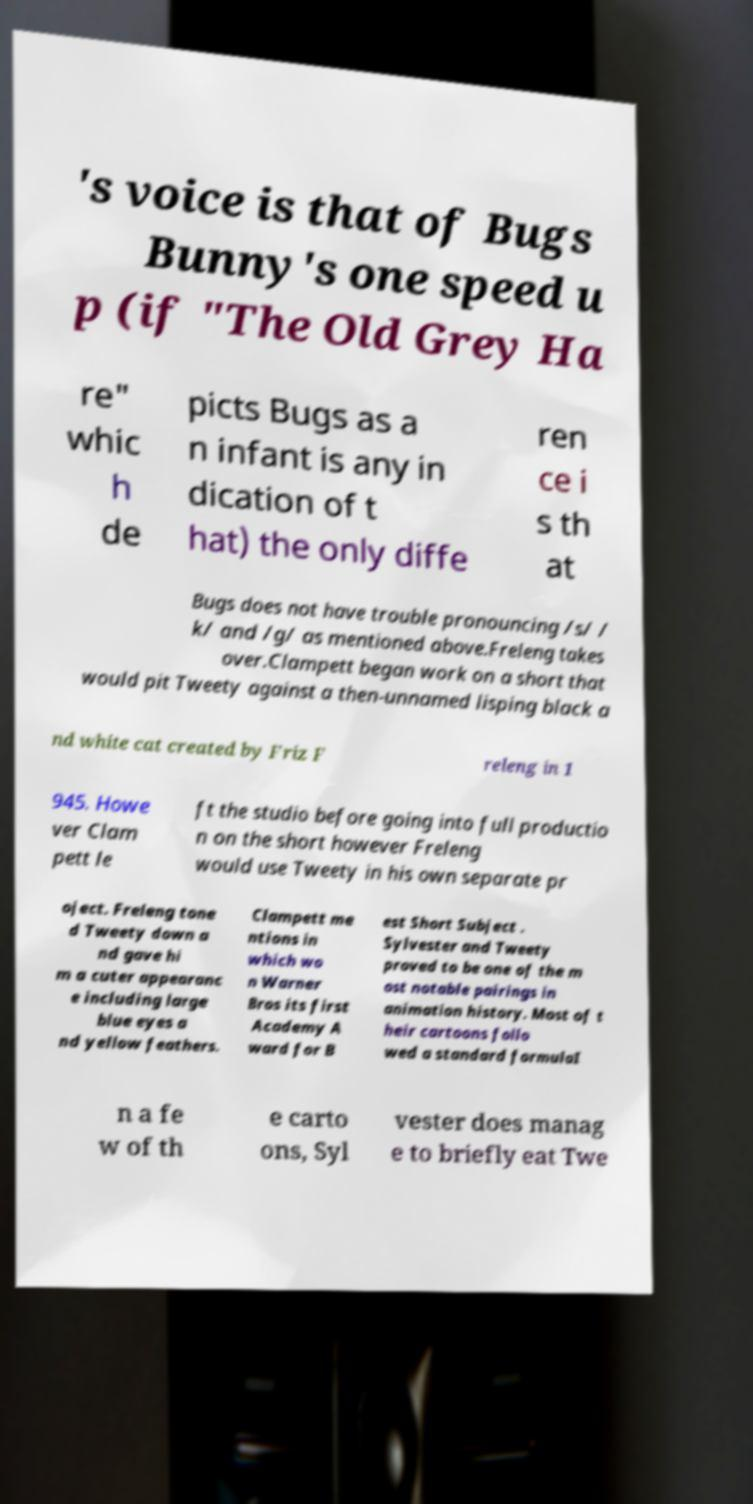For documentation purposes, I need the text within this image transcribed. Could you provide that? 's voice is that of Bugs Bunny's one speed u p (if "The Old Grey Ha re" whic h de picts Bugs as a n infant is any in dication of t hat) the only diffe ren ce i s th at Bugs does not have trouble pronouncing /s/ / k/ and /g/ as mentioned above.Freleng takes over.Clampett began work on a short that would pit Tweety against a then-unnamed lisping black a nd white cat created by Friz F releng in 1 945. Howe ver Clam pett le ft the studio before going into full productio n on the short however Freleng would use Tweety in his own separate pr oject. Freleng tone d Tweety down a nd gave hi m a cuter appearanc e including large blue eyes a nd yellow feathers. Clampett me ntions in which wo n Warner Bros its first Academy A ward for B est Short Subject . Sylvester and Tweety proved to be one of the m ost notable pairings in animation history. Most of t heir cartoons follo wed a standard formulaI n a fe w of th e carto ons, Syl vester does manag e to briefly eat Twe 